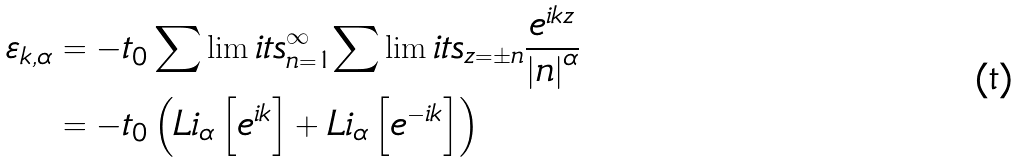Convert formula to latex. <formula><loc_0><loc_0><loc_500><loc_500>\varepsilon _ { k , \alpha } & = - t _ { 0 } \sum \lim i t s _ { n = 1 } ^ { \infty } { \sum \lim i t s _ { z = \pm n } { \frac { { e ^ { i k z } } } { \left | n \right | ^ { \alpha } } } } \\ & = - t _ { 0 } \left ( L i _ { \alpha } \left [ e ^ { i k } \right ] + L i _ { \alpha } \left [ e ^ { - i k } \right ] \right )</formula> 